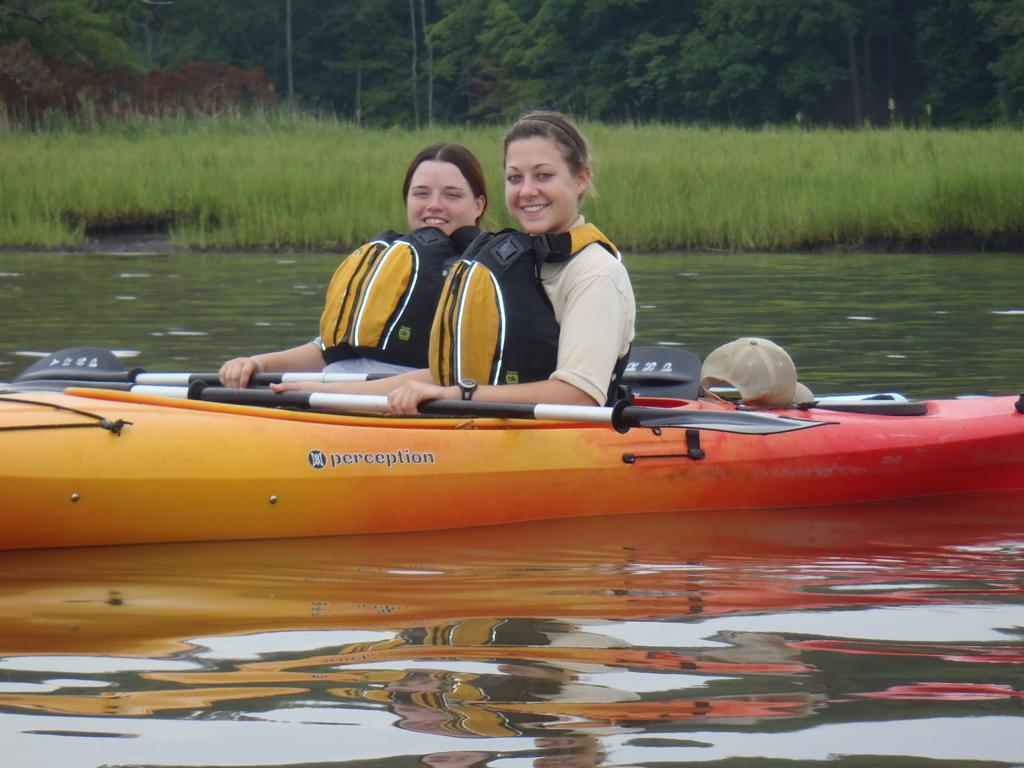How many women are in the image? There are two women in the image. What are the women wearing? The women are wearing life jackets. What type of boat are the women in? The women are in an orange color boat. What is the boat doing in the image? The boat is floating on the water. What can be seen in the background of the image? There is grass and trees visible in the background of the image. What type of flowers can be seen growing on the guitar in the image? There is no guitar or flowers present in the image. 